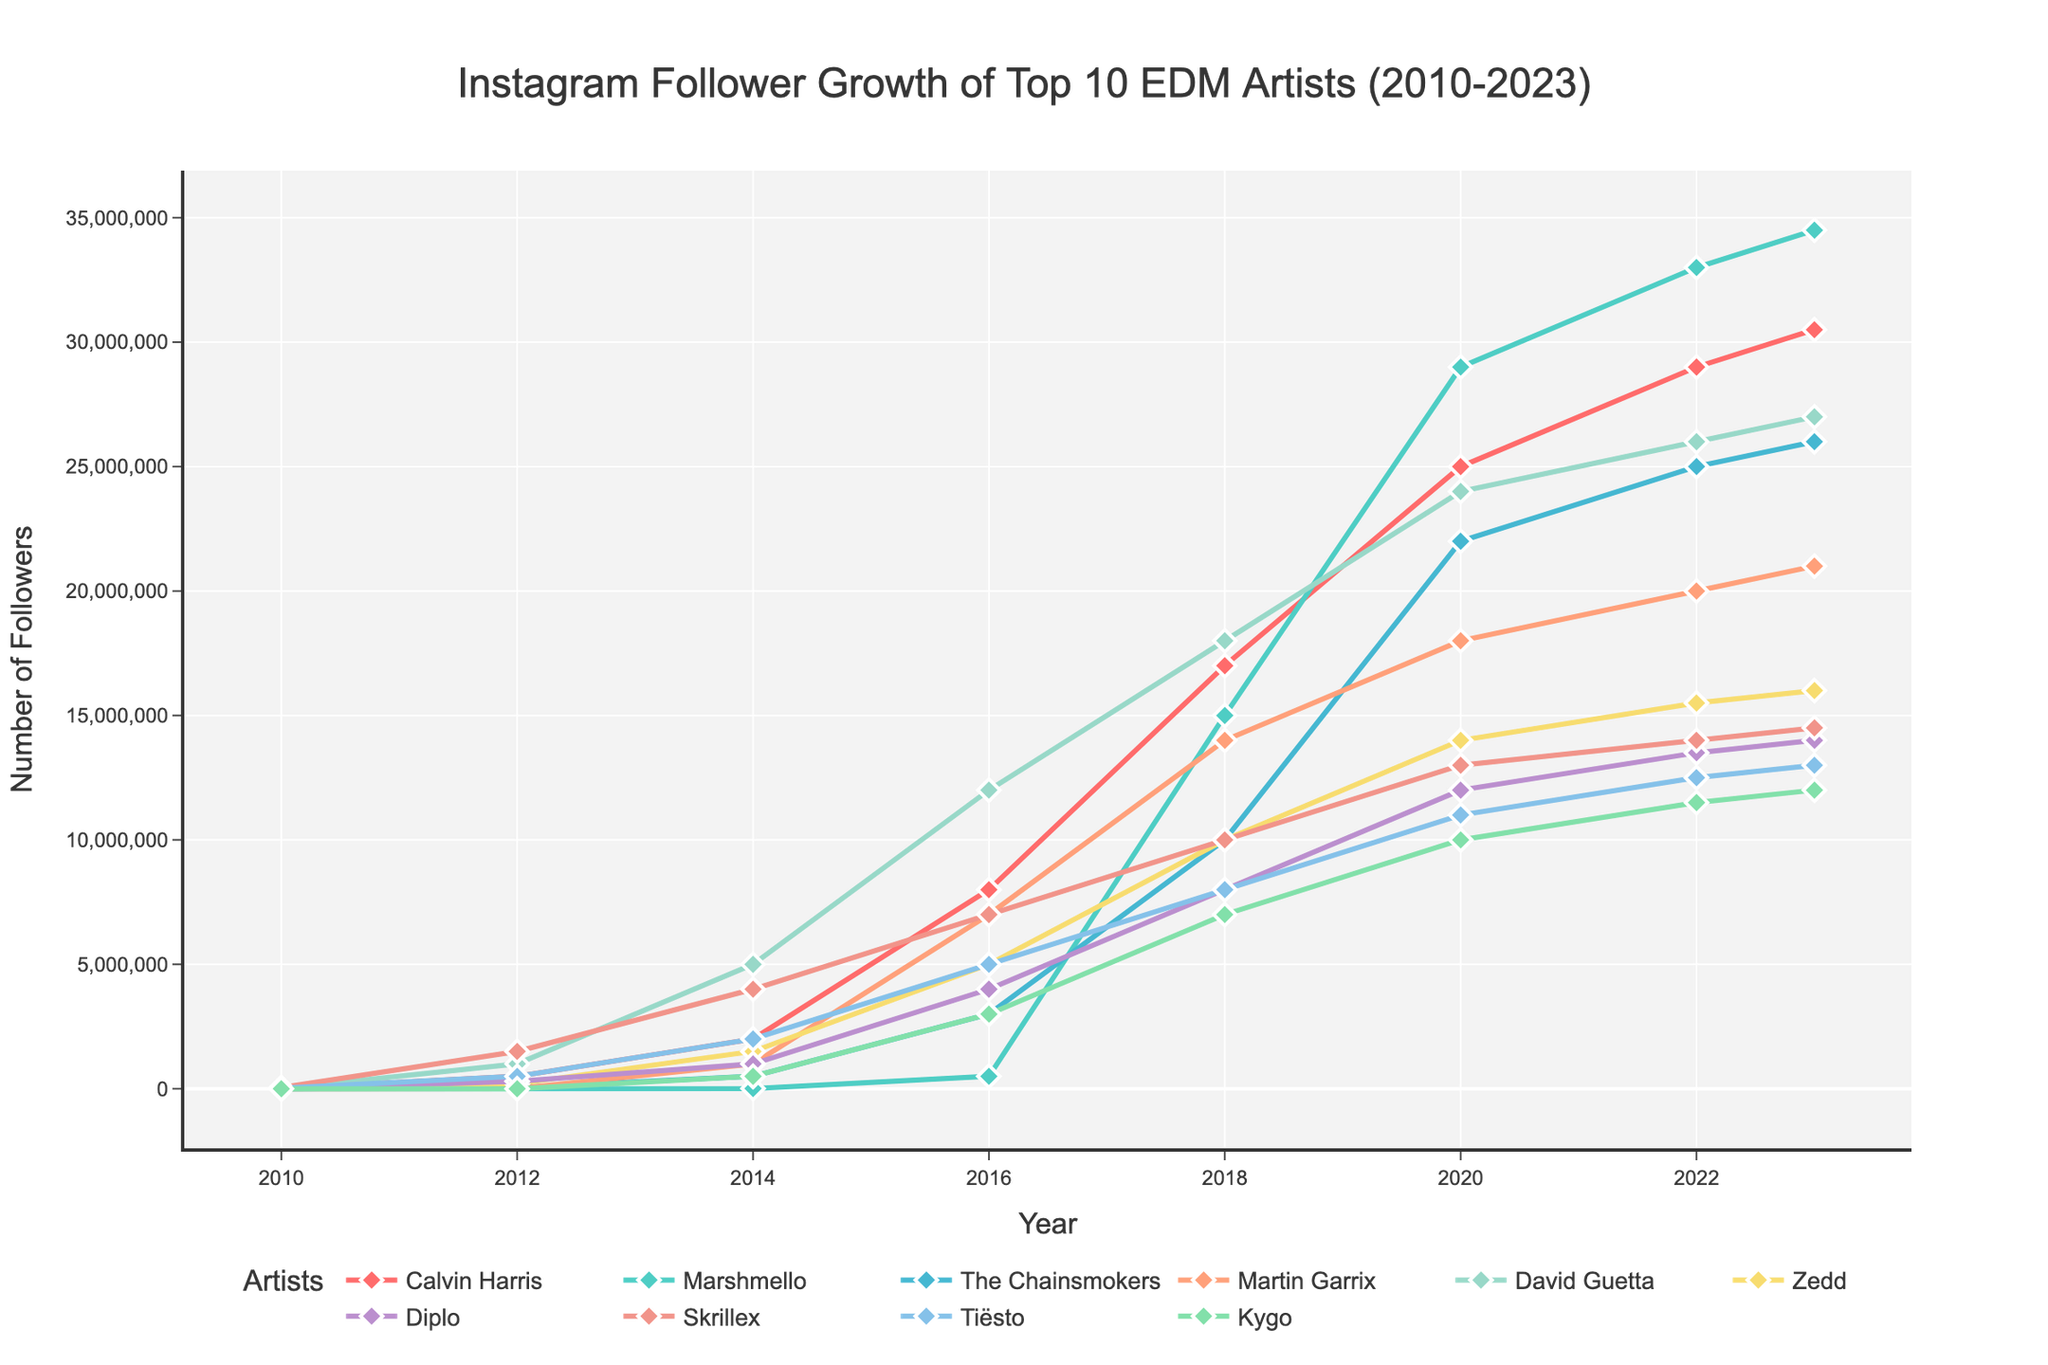What's the trend in Instagram follower growth for Calvin Harris from 2010 to 2023? To determine the trend, look at how Calvin Harris's follower count changes from 2010 (5,000) to 2023 (30.5 million). The growth is consistently increasing, with sharper rises after 2014.
Answer: Consistently increasing Who had the highest number of Instagram followers in 2023? Compare the follower counts for all artists in 2023. Marshmello has the highest number with 34.5 million followers.
Answer: Marshmello Between 2018 and 2023, which artist saw the largest increase in followers? Calculate the follower increase for each artist between 2018 and 2023 and identify the largest one. Marshmello grew from 15 million to 34.5 million, a 19.5 million increase.
Answer: Marshmello Which artist had the smallest number of followers in 2010, and how many did they have? Review the follower counts for 2010. Marshmello, Martin Garrix, and Kygo had the smallest count with 0 followers.
Answer: Marshmello, Martin Garrix, Kygo How did David Guetta’s Instagram followers change over time, and what pattern does this suggest? Look at the data points for David Guetta from 2010 to 2023. His followers increased steadily from 10,000 in 2010 to 27 million in 2023, suggesting continuous growth.
Answer: Continuous growth During which period did The Chainsmokers experience the most rapid follower growth? Check the increments between each data point for The Chainsmokers. The period from 2014 (500,000) to 2016 (3,000,000) shows the most rapid growth.
Answer: 2014 to 2016 Who experienced a higher total follower growth from 2010 to 2023: Zedd or Skrillex? Calculate the follower growth from 2010 to 2023 for both Zedd (16,000,000 - 2,000) and Skrillex (14,500,000 - 50,000). Zedd grew by 15,998,000, while Skrillex grew by 14,450,000.
Answer: Zedd Compare the total growth of Calvin Harris and Diplo from 2010 to 2023. Who grew more, and by how much? Calvin Harris grew from 5,000 to 30,500,000 (30,495,000), and Diplo grew from 5,000 to 14,000,000 (13,995,000). Calvin Harris grew more by 16,500,000.
Answer: Calvin Harris, 16,500,000 Which artist had a consistent growth pattern with no drops in followers from 2010 to 2023? Identify any artist whose followers never decrease year-over-year. All artists show consistent growth with no drops in the provided data.
Answer: All artists What’s the average number of followers for Martin Garrix between 2014 and 2023? Sum the follower counts from 2014 (1,000,000), 2016 (7,000,000), 2018 (14,000,000), 2020 (18,000,000), 2022 (20,000,000), and 2023 (21,000,000), then divide by 6. Average = (1,000,000 + 7,000,000 + 14,000,000 + 18,000,000 + 20,000,000 + 21,000,000) / 6 = 13,500,000.
Answer: 13,500,000 